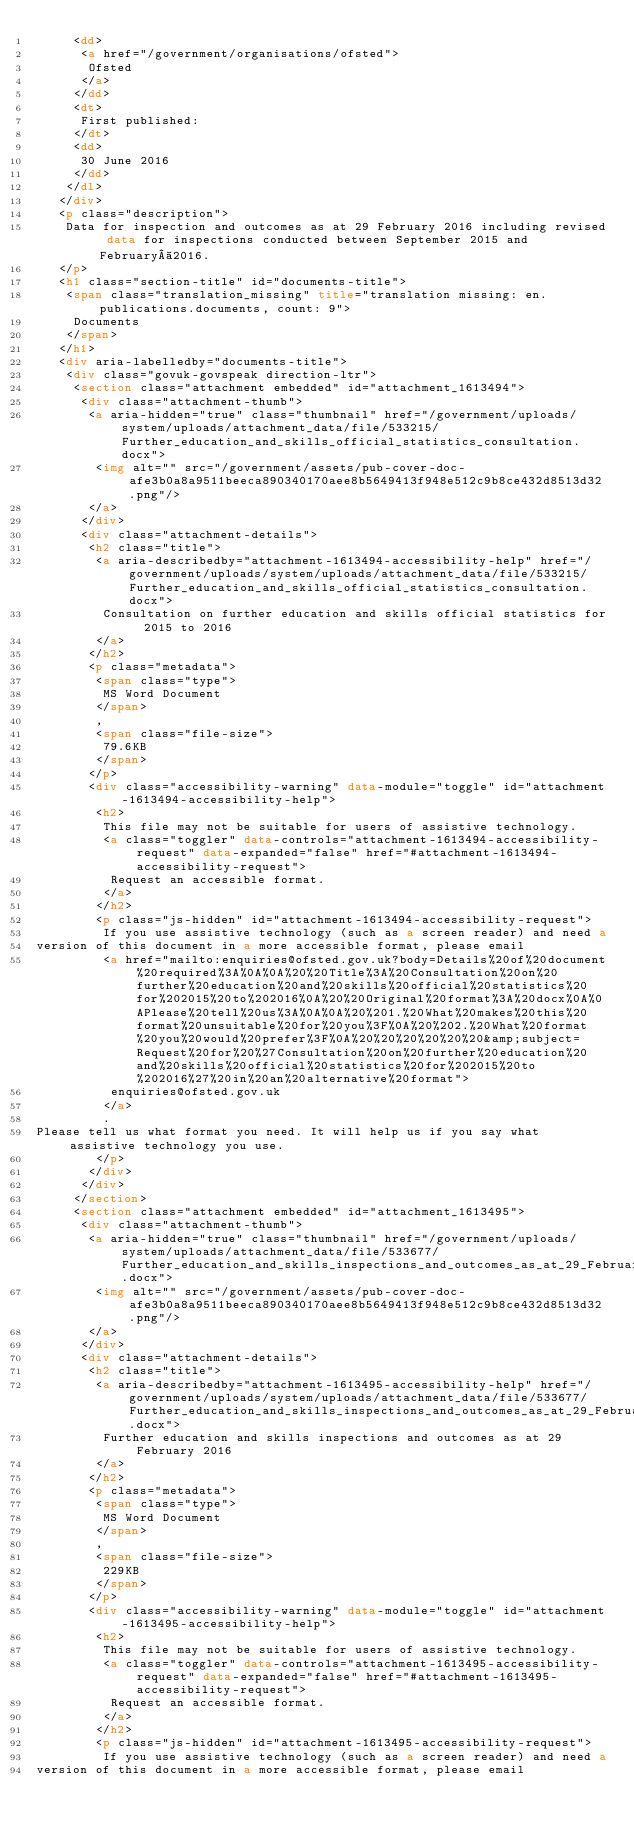<code> <loc_0><loc_0><loc_500><loc_500><_HTML_>     <dd>
      <a href="/government/organisations/ofsted">
       Ofsted
      </a>
     </dd>
     <dt>
      First published:
     </dt>
     <dd>
      30 June 2016
     </dd>
    </dl>
   </div>
   <p class="description">
    Data for inspection and outcomes as at 29 February 2016 including revised data for inspections conducted between September 2015 and February 2016.
   </p>
   <h1 class="section-title" id="documents-title">
    <span class="translation_missing" title="translation missing: en.publications.documents, count: 9">
     Documents
    </span>
   </h1>
   <div aria-labelledby="documents-title">
    <div class="govuk-govspeak direction-ltr">
     <section class="attachment embedded" id="attachment_1613494">
      <div class="attachment-thumb">
       <a aria-hidden="true" class="thumbnail" href="/government/uploads/system/uploads/attachment_data/file/533215/Further_education_and_skills_official_statistics_consultation.docx">
        <img alt="" src="/government/assets/pub-cover-doc-afe3b0a8a9511beeca890340170aee8b5649413f948e512c9b8ce432d8513d32.png"/>
       </a>
      </div>
      <div class="attachment-details">
       <h2 class="title">
        <a aria-describedby="attachment-1613494-accessibility-help" href="/government/uploads/system/uploads/attachment_data/file/533215/Further_education_and_skills_official_statistics_consultation.docx">
         Consultation on further education and skills official statistics for 2015 to 2016
        </a>
       </h2>
       <p class="metadata">
        <span class="type">
         MS Word Document
        </span>
        ,
        <span class="file-size">
         79.6KB
        </span>
       </p>
       <div class="accessibility-warning" data-module="toggle" id="attachment-1613494-accessibility-help">
        <h2>
         This file may not be suitable for users of assistive technology.
         <a class="toggler" data-controls="attachment-1613494-accessibility-request" data-expanded="false" href="#attachment-1613494-accessibility-request">
          Request an accessible format.
         </a>
        </h2>
        <p class="js-hidden" id="attachment-1613494-accessibility-request">
         If you use assistive technology (such as a screen reader) and need a
version of this document in a more accessible format, please email
         <a href="mailto:enquiries@ofsted.gov.uk?body=Details%20of%20document%20required%3A%0A%0A%20%20Title%3A%20Consultation%20on%20further%20education%20and%20skills%20official%20statistics%20for%202015%20to%202016%0A%20%20Original%20format%3A%20docx%0A%0APlease%20tell%20us%3A%0A%0A%20%201.%20What%20makes%20this%20format%20unsuitable%20for%20you%3F%0A%20%202.%20What%20format%20you%20would%20prefer%3F%0A%20%20%20%20%20%20&amp;subject=Request%20for%20%27Consultation%20on%20further%20education%20and%20skills%20official%20statistics%20for%202015%20to%202016%27%20in%20an%20alternative%20format">
          enquiries@ofsted.gov.uk
         </a>
         .
Please tell us what format you need. It will help us if you say what assistive technology you use.
        </p>
       </div>
      </div>
     </section>
     <section class="attachment embedded" id="attachment_1613495">
      <div class="attachment-thumb">
       <a aria-hidden="true" class="thumbnail" href="/government/uploads/system/uploads/attachment_data/file/533677/Further_education_and_skills_inspections_and_outcomes_as_at_29_February_2016.docx">
        <img alt="" src="/government/assets/pub-cover-doc-afe3b0a8a9511beeca890340170aee8b5649413f948e512c9b8ce432d8513d32.png"/>
       </a>
      </div>
      <div class="attachment-details">
       <h2 class="title">
        <a aria-describedby="attachment-1613495-accessibility-help" href="/government/uploads/system/uploads/attachment_data/file/533677/Further_education_and_skills_inspections_and_outcomes_as_at_29_February_2016.docx">
         Further education and skills inspections and outcomes as at 29 February 2016
        </a>
       </h2>
       <p class="metadata">
        <span class="type">
         MS Word Document
        </span>
        ,
        <span class="file-size">
         229KB
        </span>
       </p>
       <div class="accessibility-warning" data-module="toggle" id="attachment-1613495-accessibility-help">
        <h2>
         This file may not be suitable for users of assistive technology.
         <a class="toggler" data-controls="attachment-1613495-accessibility-request" data-expanded="false" href="#attachment-1613495-accessibility-request">
          Request an accessible format.
         </a>
        </h2>
        <p class="js-hidden" id="attachment-1613495-accessibility-request">
         If you use assistive technology (such as a screen reader) and need a
version of this document in a more accessible format, please email</code> 